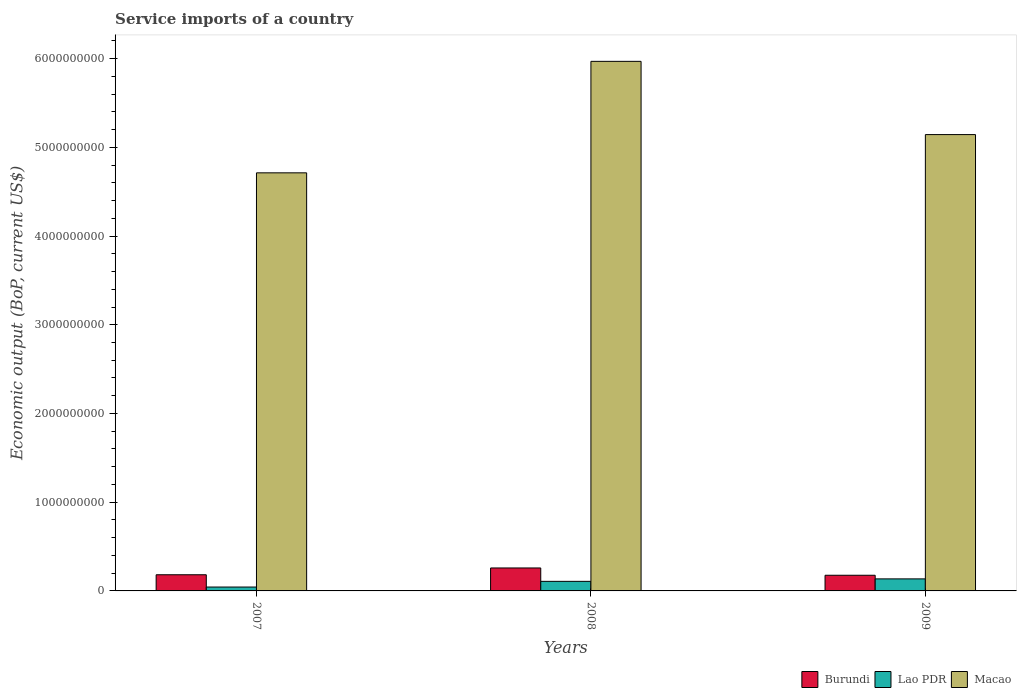How many different coloured bars are there?
Your answer should be very brief. 3. Are the number of bars on each tick of the X-axis equal?
Your response must be concise. Yes. What is the service imports in Burundi in 2009?
Ensure brevity in your answer.  1.77e+08. Across all years, what is the maximum service imports in Macao?
Keep it short and to the point. 5.97e+09. Across all years, what is the minimum service imports in Burundi?
Make the answer very short. 1.77e+08. What is the total service imports in Lao PDR in the graph?
Give a very brief answer. 2.87e+08. What is the difference between the service imports in Macao in 2008 and that in 2009?
Your response must be concise. 8.25e+08. What is the difference between the service imports in Macao in 2008 and the service imports in Burundi in 2009?
Your response must be concise. 5.79e+09. What is the average service imports in Lao PDR per year?
Your answer should be compact. 9.58e+07. In the year 2009, what is the difference between the service imports in Burundi and service imports in Macao?
Offer a very short reply. -4.97e+09. What is the ratio of the service imports in Lao PDR in 2007 to that in 2008?
Provide a short and direct response. 0.41. Is the service imports in Lao PDR in 2007 less than that in 2009?
Offer a terse response. Yes. What is the difference between the highest and the second highest service imports in Burundi?
Keep it short and to the point. 7.66e+07. What is the difference between the highest and the lowest service imports in Lao PDR?
Offer a very short reply. 9.18e+07. What does the 3rd bar from the left in 2007 represents?
Your response must be concise. Macao. What does the 3rd bar from the right in 2008 represents?
Your response must be concise. Burundi. What is the difference between two consecutive major ticks on the Y-axis?
Offer a terse response. 1.00e+09. How many legend labels are there?
Offer a very short reply. 3. How are the legend labels stacked?
Keep it short and to the point. Horizontal. What is the title of the graph?
Ensure brevity in your answer.  Service imports of a country. Does "Dominica" appear as one of the legend labels in the graph?
Provide a succinct answer. No. What is the label or title of the Y-axis?
Ensure brevity in your answer.  Economic output (BoP, current US$). What is the Economic output (BoP, current US$) of Burundi in 2007?
Make the answer very short. 1.82e+08. What is the Economic output (BoP, current US$) in Lao PDR in 2007?
Give a very brief answer. 4.38e+07. What is the Economic output (BoP, current US$) of Macao in 2007?
Offer a terse response. 4.71e+09. What is the Economic output (BoP, current US$) in Burundi in 2008?
Make the answer very short. 2.59e+08. What is the Economic output (BoP, current US$) of Lao PDR in 2008?
Offer a very short reply. 1.08e+08. What is the Economic output (BoP, current US$) of Macao in 2008?
Provide a succinct answer. 5.97e+09. What is the Economic output (BoP, current US$) in Burundi in 2009?
Your response must be concise. 1.77e+08. What is the Economic output (BoP, current US$) of Lao PDR in 2009?
Ensure brevity in your answer.  1.36e+08. What is the Economic output (BoP, current US$) in Macao in 2009?
Offer a very short reply. 5.14e+09. Across all years, what is the maximum Economic output (BoP, current US$) of Burundi?
Keep it short and to the point. 2.59e+08. Across all years, what is the maximum Economic output (BoP, current US$) in Lao PDR?
Make the answer very short. 1.36e+08. Across all years, what is the maximum Economic output (BoP, current US$) of Macao?
Ensure brevity in your answer.  5.97e+09. Across all years, what is the minimum Economic output (BoP, current US$) of Burundi?
Offer a terse response. 1.77e+08. Across all years, what is the minimum Economic output (BoP, current US$) in Lao PDR?
Your answer should be very brief. 4.38e+07. Across all years, what is the minimum Economic output (BoP, current US$) in Macao?
Ensure brevity in your answer.  4.71e+09. What is the total Economic output (BoP, current US$) of Burundi in the graph?
Offer a very short reply. 6.18e+08. What is the total Economic output (BoP, current US$) in Lao PDR in the graph?
Provide a short and direct response. 2.87e+08. What is the total Economic output (BoP, current US$) in Macao in the graph?
Provide a short and direct response. 1.58e+1. What is the difference between the Economic output (BoP, current US$) in Burundi in 2007 and that in 2008?
Offer a terse response. -7.66e+07. What is the difference between the Economic output (BoP, current US$) in Lao PDR in 2007 and that in 2008?
Offer a terse response. -6.41e+07. What is the difference between the Economic output (BoP, current US$) in Macao in 2007 and that in 2008?
Your response must be concise. -1.26e+09. What is the difference between the Economic output (BoP, current US$) of Burundi in 2007 and that in 2009?
Keep it short and to the point. 5.50e+06. What is the difference between the Economic output (BoP, current US$) of Lao PDR in 2007 and that in 2009?
Ensure brevity in your answer.  -9.18e+07. What is the difference between the Economic output (BoP, current US$) in Macao in 2007 and that in 2009?
Offer a terse response. -4.31e+08. What is the difference between the Economic output (BoP, current US$) of Burundi in 2008 and that in 2009?
Offer a very short reply. 8.21e+07. What is the difference between the Economic output (BoP, current US$) in Lao PDR in 2008 and that in 2009?
Your answer should be compact. -2.77e+07. What is the difference between the Economic output (BoP, current US$) in Macao in 2008 and that in 2009?
Provide a succinct answer. 8.25e+08. What is the difference between the Economic output (BoP, current US$) of Burundi in 2007 and the Economic output (BoP, current US$) of Lao PDR in 2008?
Make the answer very short. 7.42e+07. What is the difference between the Economic output (BoP, current US$) in Burundi in 2007 and the Economic output (BoP, current US$) in Macao in 2008?
Offer a terse response. -5.79e+09. What is the difference between the Economic output (BoP, current US$) of Lao PDR in 2007 and the Economic output (BoP, current US$) of Macao in 2008?
Ensure brevity in your answer.  -5.93e+09. What is the difference between the Economic output (BoP, current US$) of Burundi in 2007 and the Economic output (BoP, current US$) of Lao PDR in 2009?
Make the answer very short. 4.65e+07. What is the difference between the Economic output (BoP, current US$) in Burundi in 2007 and the Economic output (BoP, current US$) in Macao in 2009?
Your answer should be very brief. -4.96e+09. What is the difference between the Economic output (BoP, current US$) of Lao PDR in 2007 and the Economic output (BoP, current US$) of Macao in 2009?
Your answer should be compact. -5.10e+09. What is the difference between the Economic output (BoP, current US$) of Burundi in 2008 and the Economic output (BoP, current US$) of Lao PDR in 2009?
Your response must be concise. 1.23e+08. What is the difference between the Economic output (BoP, current US$) in Burundi in 2008 and the Economic output (BoP, current US$) in Macao in 2009?
Offer a terse response. -4.88e+09. What is the difference between the Economic output (BoP, current US$) in Lao PDR in 2008 and the Economic output (BoP, current US$) in Macao in 2009?
Provide a short and direct response. -5.04e+09. What is the average Economic output (BoP, current US$) in Burundi per year?
Your answer should be very brief. 2.06e+08. What is the average Economic output (BoP, current US$) of Lao PDR per year?
Offer a very short reply. 9.58e+07. What is the average Economic output (BoP, current US$) in Macao per year?
Keep it short and to the point. 5.28e+09. In the year 2007, what is the difference between the Economic output (BoP, current US$) in Burundi and Economic output (BoP, current US$) in Lao PDR?
Offer a very short reply. 1.38e+08. In the year 2007, what is the difference between the Economic output (BoP, current US$) of Burundi and Economic output (BoP, current US$) of Macao?
Your response must be concise. -4.53e+09. In the year 2007, what is the difference between the Economic output (BoP, current US$) of Lao PDR and Economic output (BoP, current US$) of Macao?
Provide a succinct answer. -4.67e+09. In the year 2008, what is the difference between the Economic output (BoP, current US$) in Burundi and Economic output (BoP, current US$) in Lao PDR?
Your response must be concise. 1.51e+08. In the year 2008, what is the difference between the Economic output (BoP, current US$) in Burundi and Economic output (BoP, current US$) in Macao?
Give a very brief answer. -5.71e+09. In the year 2008, what is the difference between the Economic output (BoP, current US$) in Lao PDR and Economic output (BoP, current US$) in Macao?
Offer a very short reply. -5.86e+09. In the year 2009, what is the difference between the Economic output (BoP, current US$) of Burundi and Economic output (BoP, current US$) of Lao PDR?
Your answer should be very brief. 4.10e+07. In the year 2009, what is the difference between the Economic output (BoP, current US$) in Burundi and Economic output (BoP, current US$) in Macao?
Make the answer very short. -4.97e+09. In the year 2009, what is the difference between the Economic output (BoP, current US$) of Lao PDR and Economic output (BoP, current US$) of Macao?
Offer a terse response. -5.01e+09. What is the ratio of the Economic output (BoP, current US$) in Burundi in 2007 to that in 2008?
Give a very brief answer. 0.7. What is the ratio of the Economic output (BoP, current US$) in Lao PDR in 2007 to that in 2008?
Ensure brevity in your answer.  0.41. What is the ratio of the Economic output (BoP, current US$) of Macao in 2007 to that in 2008?
Your answer should be compact. 0.79. What is the ratio of the Economic output (BoP, current US$) in Burundi in 2007 to that in 2009?
Offer a terse response. 1.03. What is the ratio of the Economic output (BoP, current US$) of Lao PDR in 2007 to that in 2009?
Provide a short and direct response. 0.32. What is the ratio of the Economic output (BoP, current US$) in Macao in 2007 to that in 2009?
Your answer should be compact. 0.92. What is the ratio of the Economic output (BoP, current US$) in Burundi in 2008 to that in 2009?
Ensure brevity in your answer.  1.47. What is the ratio of the Economic output (BoP, current US$) in Lao PDR in 2008 to that in 2009?
Keep it short and to the point. 0.8. What is the ratio of the Economic output (BoP, current US$) of Macao in 2008 to that in 2009?
Your answer should be very brief. 1.16. What is the difference between the highest and the second highest Economic output (BoP, current US$) in Burundi?
Keep it short and to the point. 7.66e+07. What is the difference between the highest and the second highest Economic output (BoP, current US$) of Lao PDR?
Your answer should be compact. 2.77e+07. What is the difference between the highest and the second highest Economic output (BoP, current US$) of Macao?
Offer a very short reply. 8.25e+08. What is the difference between the highest and the lowest Economic output (BoP, current US$) of Burundi?
Ensure brevity in your answer.  8.21e+07. What is the difference between the highest and the lowest Economic output (BoP, current US$) in Lao PDR?
Provide a succinct answer. 9.18e+07. What is the difference between the highest and the lowest Economic output (BoP, current US$) of Macao?
Make the answer very short. 1.26e+09. 